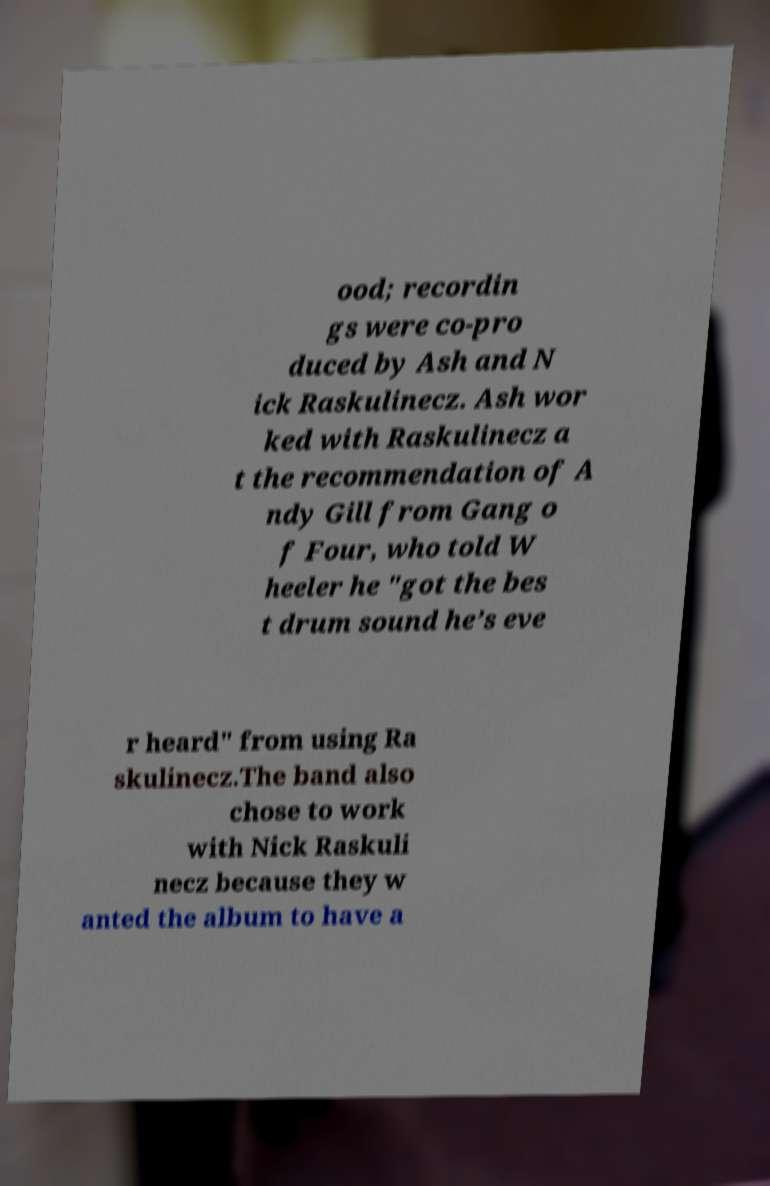For documentation purposes, I need the text within this image transcribed. Could you provide that? ood; recordin gs were co-pro duced by Ash and N ick Raskulinecz. Ash wor ked with Raskulinecz a t the recommendation of A ndy Gill from Gang o f Four, who told W heeler he "got the bes t drum sound he’s eve r heard" from using Ra skulinecz.The band also chose to work with Nick Raskuli necz because they w anted the album to have a 